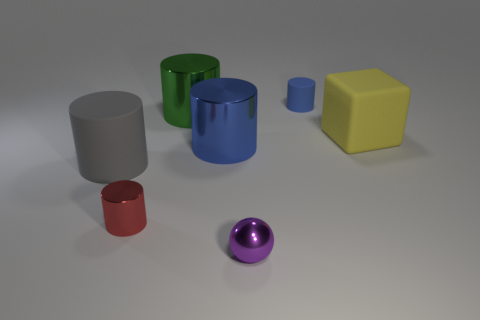Can you describe the lighting and shadows in the image? Certainly, the image features a soft overhead lighting that casts gentle, diffuse shadows directly beneath each object. The shadows are soft-edged, suggesting a light source that is not extremely close to the objects, possibly simulating ambient daylight conditions within an indoor space. 